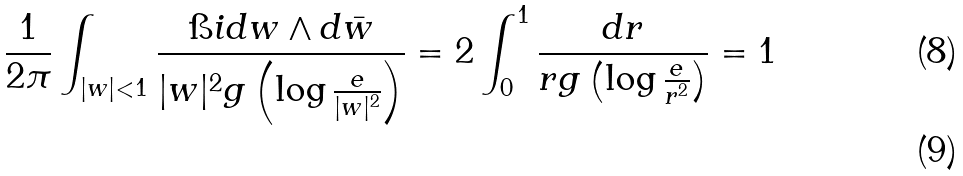<formula> <loc_0><loc_0><loc_500><loc_500>\frac { 1 } { 2 \pi } \int _ { | w | < 1 } \frac { \i i d w \wedge d \bar { w } } { | w | ^ { 2 } g \left ( \log \frac { e } { | w | ^ { 2 } } \right ) } = 2 \int _ { 0 } ^ { 1 } \frac { d r } { r g \left ( \log \frac { e } { r ^ { 2 } } \right ) } = 1 \\</formula> 